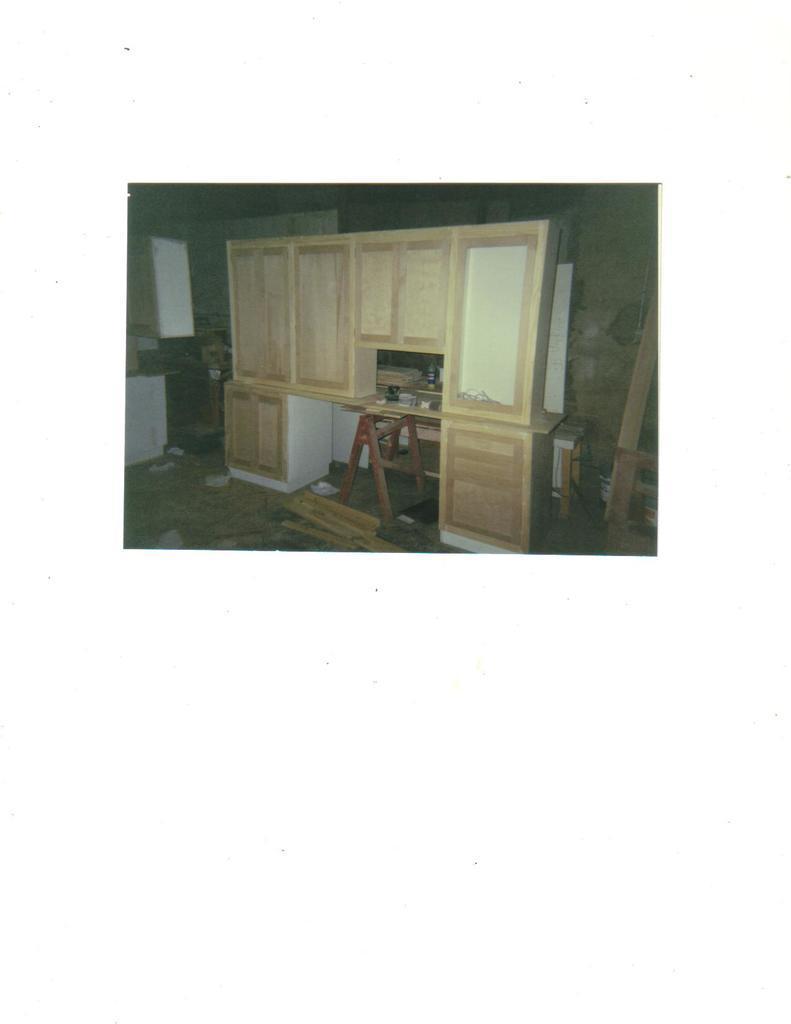Please provide a concise description of this image. This is an inside view. Here I can see a cupboard. On the left side there is a table. Some wood material and few objects are placed on the floor. In the background, I can see the wall. 